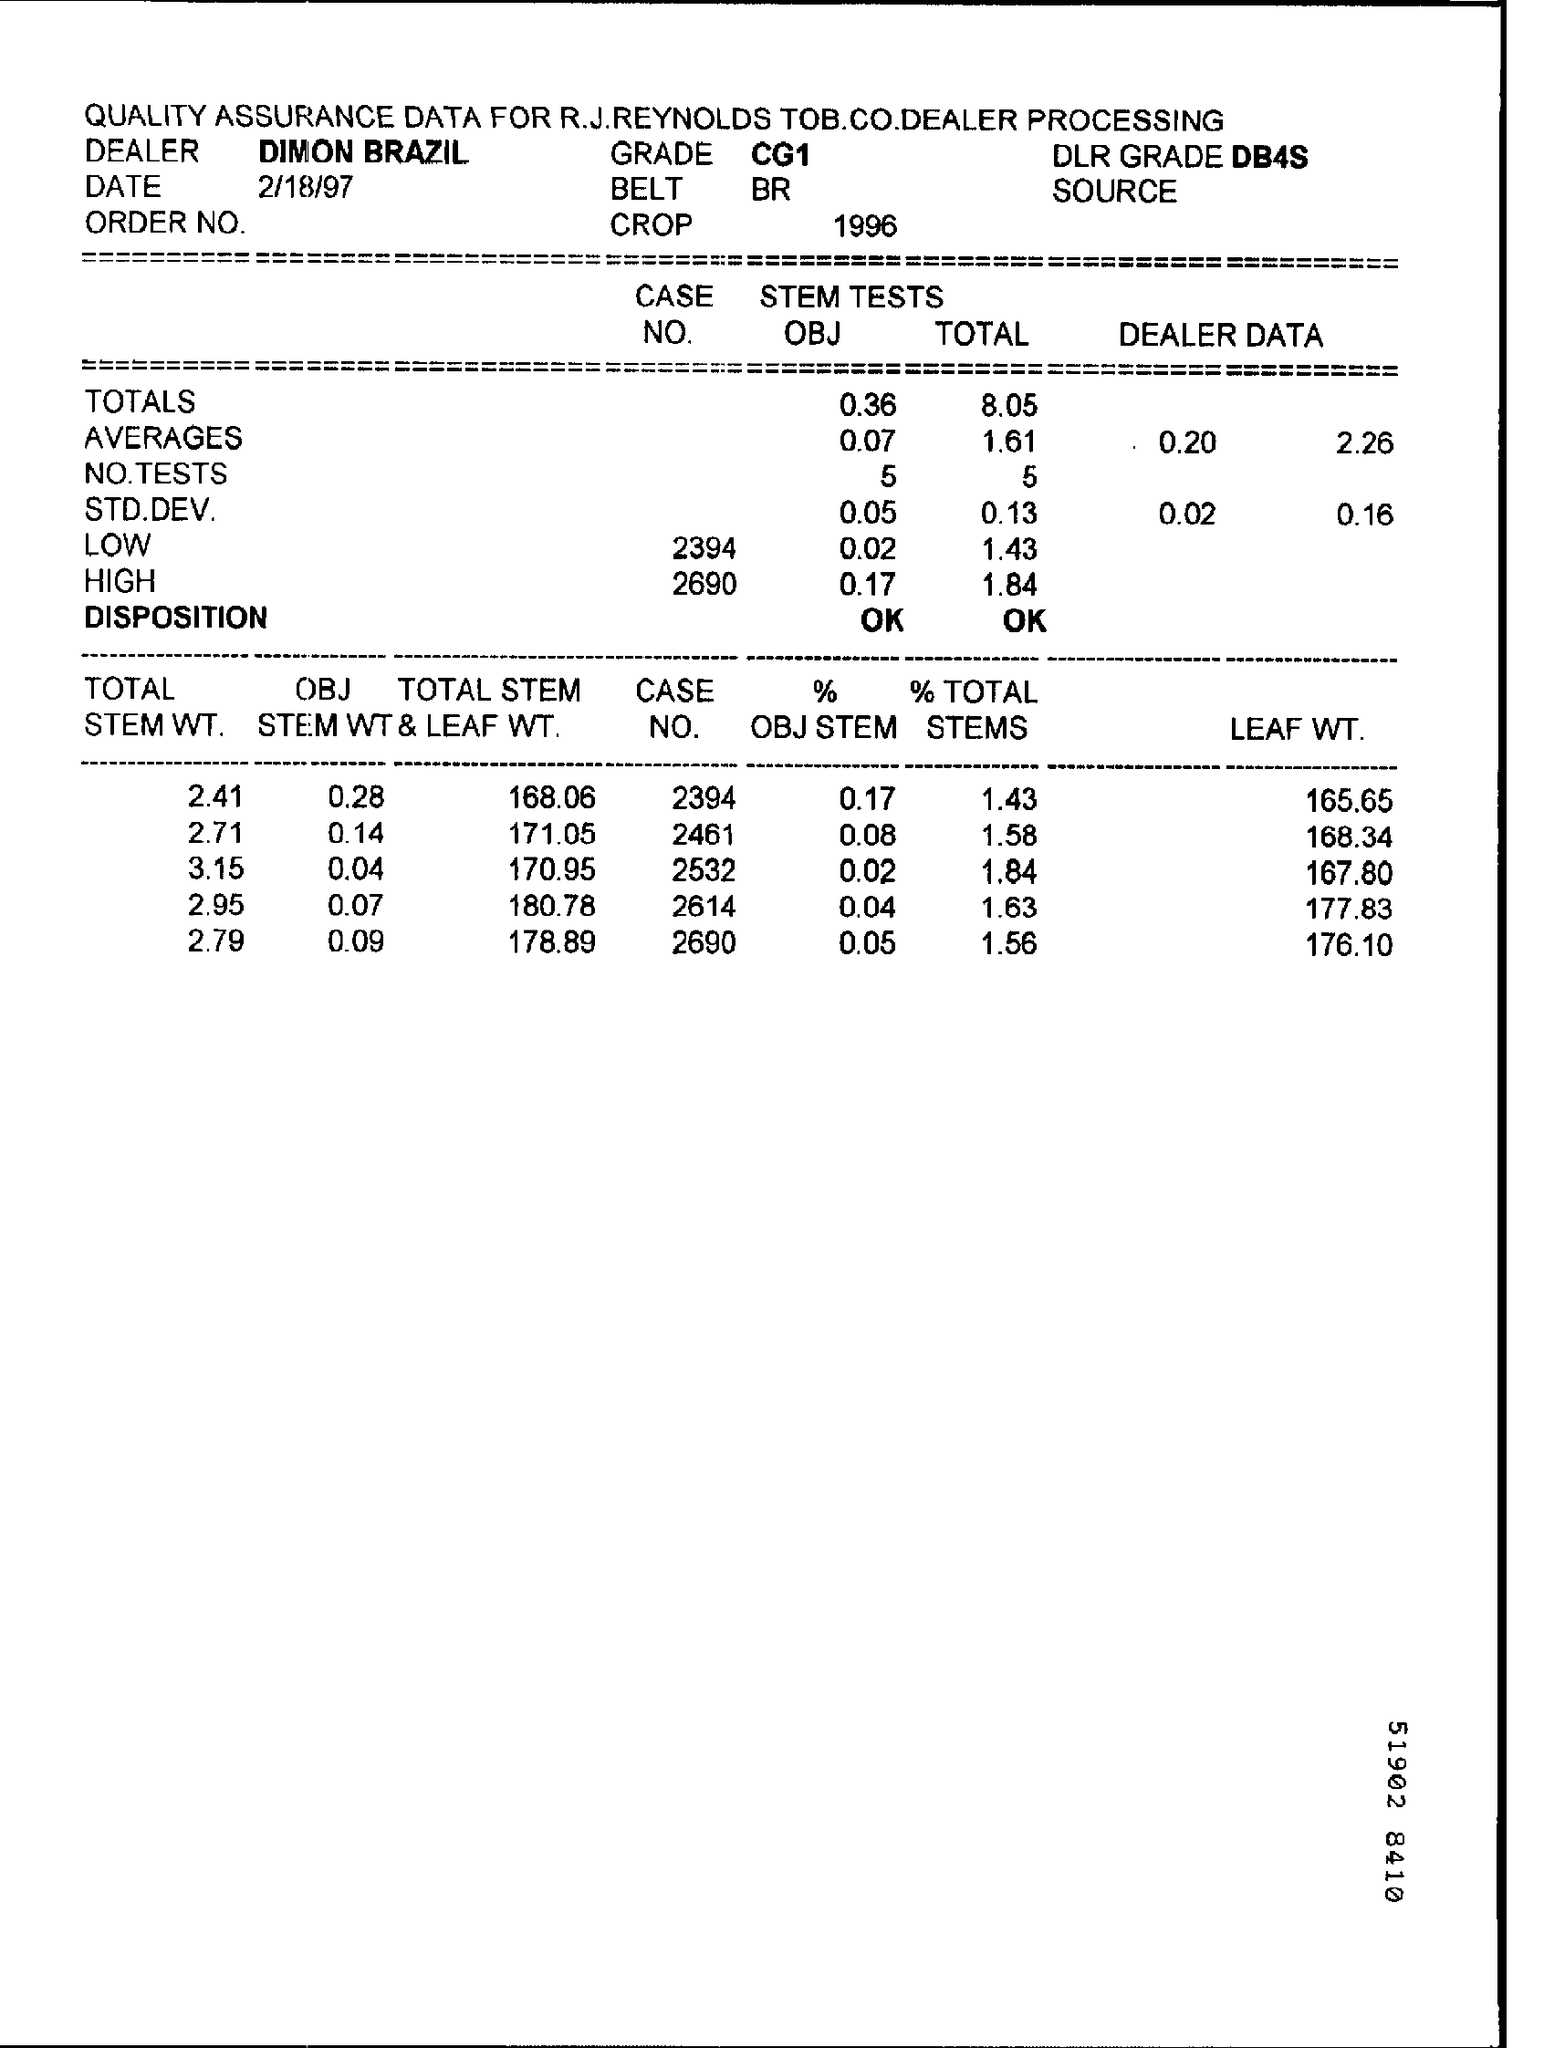Point out several critical features in this image. The grade is CG1. The DLR Grade is a measure of the quality of the information provided by the DLR satellite. The latest DLR Grade for the DB4S satellite is DB4S.. Today's date is February 18th, 1997. 